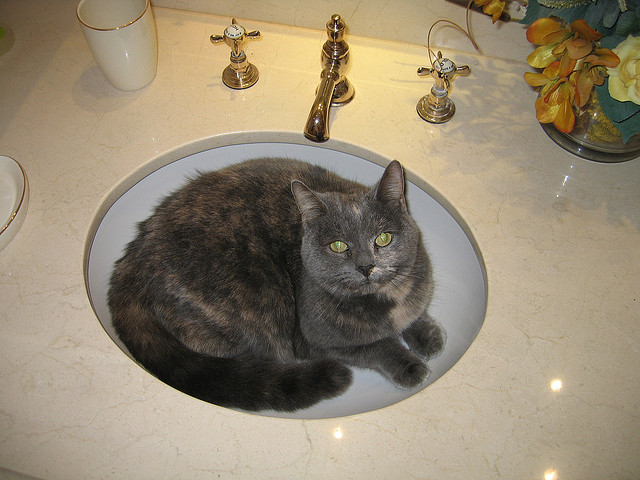What might the cat be thinking while sitting in the sink? It's possible the cat is thinking about the comfort and coolness of the sink's surface, or perhaps it's simply found a quiet spot away from the bustle of the household. Cats often seek out unique resting spots that provide a sense of security or curiosity. Do you think the cat uses the sink regularly as a resting spot? Given that the cat seems quite relaxed, it's likely that this isn't its first time in the sink. Cats are creatures of habit, and if it has had positive experiences in the sink before, it may return there frequently. 